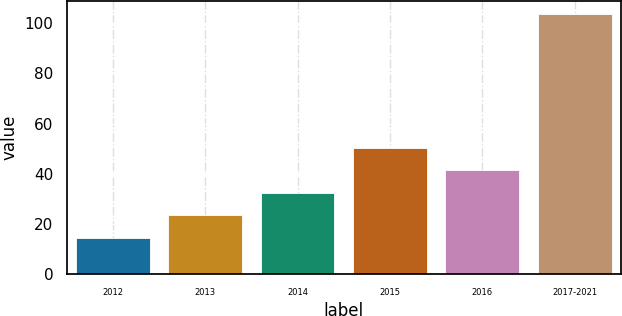Convert chart. <chart><loc_0><loc_0><loc_500><loc_500><bar_chart><fcel>2012<fcel>2013<fcel>2014<fcel>2015<fcel>2016<fcel>2017-2021<nl><fcel>14.6<fcel>23.51<fcel>32.42<fcel>50.24<fcel>41.33<fcel>103.7<nl></chart> 